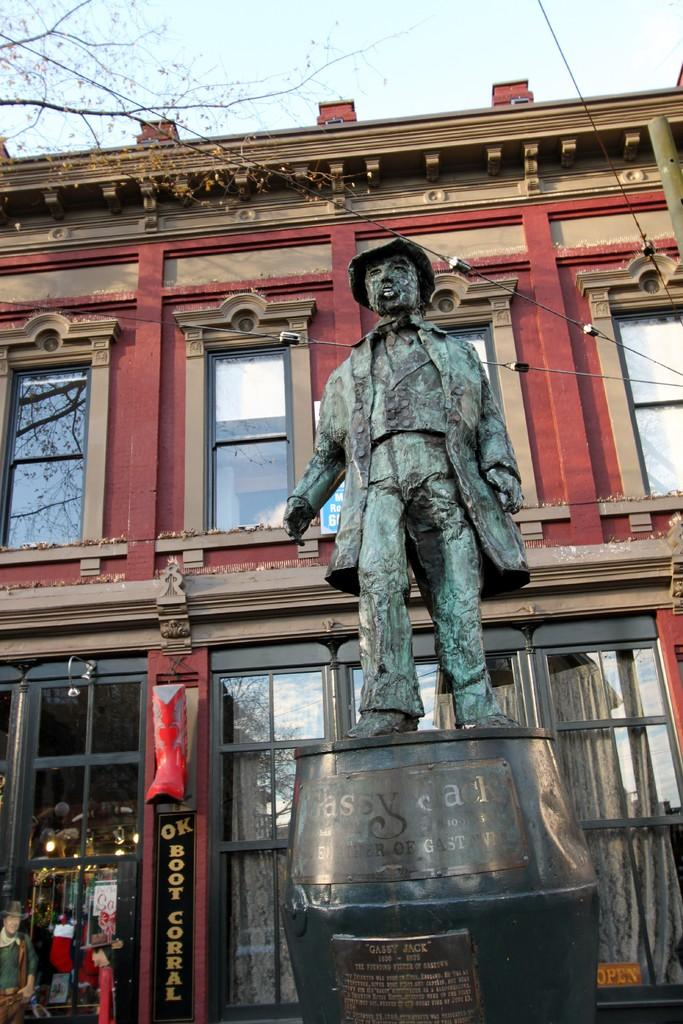What is the main subject of the image? There is a statue of a person in the image. Where is the statue located in relation to other structures? The statue is in front of a building. What can be seen at the top of the image? Tree branches and the sky are visible at the top of the image. What type of pain is the statue experiencing in the image? The statue is not a living being and therefore cannot experience pain. Can you tell me how many matches are visible in the image? There are no matches present in the image. 